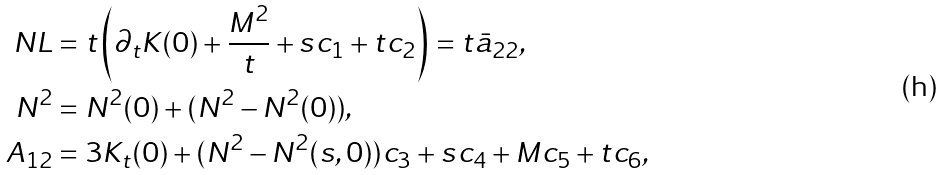<formula> <loc_0><loc_0><loc_500><loc_500>N L & = t \left ( \partial _ { t } K ( 0 ) + \frac { M ^ { 2 } } t + s c _ { 1 } + t c _ { 2 } \right ) = t \bar { a } _ { 2 2 } , \\ N ^ { 2 } & = N ^ { 2 } ( 0 ) + ( N ^ { 2 } - N ^ { 2 } ( 0 ) ) , \\ A _ { 1 2 } & = 3 K _ { t } ( 0 ) + ( N ^ { 2 } - N ^ { 2 } ( s , 0 ) ) c _ { 3 } + s c _ { 4 } + M c _ { 5 } + t c _ { 6 } ,</formula> 